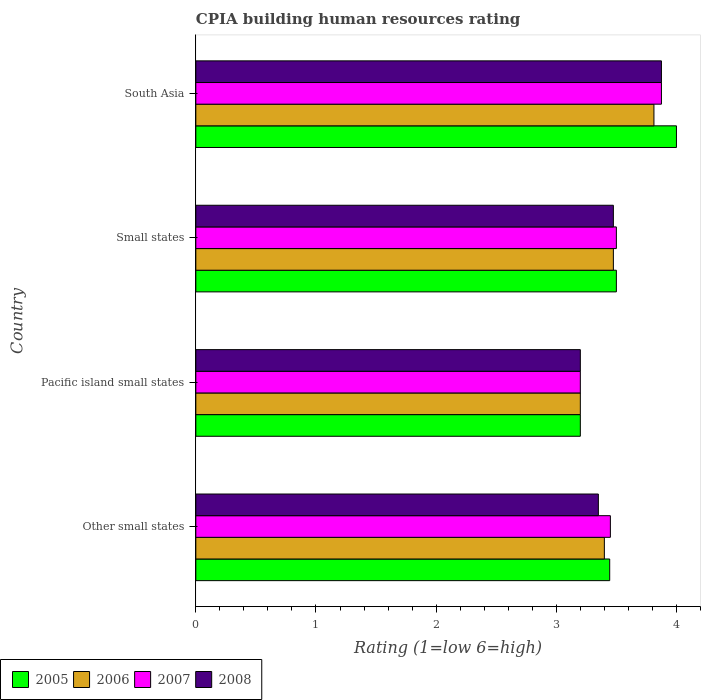How many groups of bars are there?
Keep it short and to the point. 4. Are the number of bars per tick equal to the number of legend labels?
Offer a very short reply. Yes. How many bars are there on the 2nd tick from the bottom?
Your answer should be very brief. 4. What is the label of the 2nd group of bars from the top?
Give a very brief answer. Small states. Across all countries, what is the maximum CPIA rating in 2007?
Provide a succinct answer. 3.88. Across all countries, what is the minimum CPIA rating in 2006?
Your answer should be compact. 3.2. In which country was the CPIA rating in 2005 maximum?
Your answer should be compact. South Asia. In which country was the CPIA rating in 2005 minimum?
Your response must be concise. Pacific island small states. What is the total CPIA rating in 2006 in the graph?
Your answer should be compact. 13.89. What is the difference between the CPIA rating in 2006 in Other small states and that in South Asia?
Offer a very short reply. -0.41. What is the average CPIA rating in 2008 per country?
Offer a very short reply. 3.48. What is the difference between the CPIA rating in 2006 and CPIA rating in 2005 in Small states?
Give a very brief answer. -0.02. In how many countries, is the CPIA rating in 2005 greater than 1 ?
Keep it short and to the point. 4. What is the ratio of the CPIA rating in 2006 in Pacific island small states to that in Small states?
Offer a terse response. 0.92. Is the CPIA rating in 2006 in Other small states less than that in South Asia?
Your response must be concise. Yes. Is the difference between the CPIA rating in 2006 in Other small states and Small states greater than the difference between the CPIA rating in 2005 in Other small states and Small states?
Provide a short and direct response. No. What is the difference between the highest and the lowest CPIA rating in 2007?
Give a very brief answer. 0.67. Is the sum of the CPIA rating in 2006 in Pacific island small states and Small states greater than the maximum CPIA rating in 2005 across all countries?
Your answer should be very brief. Yes. Is it the case that in every country, the sum of the CPIA rating in 2005 and CPIA rating in 2007 is greater than the sum of CPIA rating in 2008 and CPIA rating in 2006?
Ensure brevity in your answer.  No. What does the 1st bar from the top in Other small states represents?
Make the answer very short. 2008. Is it the case that in every country, the sum of the CPIA rating in 2008 and CPIA rating in 2006 is greater than the CPIA rating in 2005?
Ensure brevity in your answer.  Yes. How many bars are there?
Your answer should be very brief. 16. Are the values on the major ticks of X-axis written in scientific E-notation?
Offer a terse response. No. Does the graph contain grids?
Give a very brief answer. No. Where does the legend appear in the graph?
Provide a short and direct response. Bottom left. How many legend labels are there?
Your answer should be compact. 4. What is the title of the graph?
Offer a terse response. CPIA building human resources rating. Does "1993" appear as one of the legend labels in the graph?
Provide a short and direct response. No. What is the label or title of the Y-axis?
Your answer should be very brief. Country. What is the Rating (1=low 6=high) of 2005 in Other small states?
Provide a short and direct response. 3.44. What is the Rating (1=low 6=high) in 2007 in Other small states?
Make the answer very short. 3.45. What is the Rating (1=low 6=high) in 2008 in Other small states?
Make the answer very short. 3.35. What is the Rating (1=low 6=high) of 2005 in Pacific island small states?
Your response must be concise. 3.2. What is the Rating (1=low 6=high) of 2008 in Pacific island small states?
Ensure brevity in your answer.  3.2. What is the Rating (1=low 6=high) of 2006 in Small states?
Offer a very short reply. 3.48. What is the Rating (1=low 6=high) of 2007 in Small states?
Your answer should be compact. 3.5. What is the Rating (1=low 6=high) in 2008 in Small states?
Your answer should be very brief. 3.48. What is the Rating (1=low 6=high) in 2006 in South Asia?
Keep it short and to the point. 3.81. What is the Rating (1=low 6=high) of 2007 in South Asia?
Make the answer very short. 3.88. What is the Rating (1=low 6=high) in 2008 in South Asia?
Provide a short and direct response. 3.88. Across all countries, what is the maximum Rating (1=low 6=high) of 2006?
Offer a very short reply. 3.81. Across all countries, what is the maximum Rating (1=low 6=high) in 2007?
Give a very brief answer. 3.88. Across all countries, what is the maximum Rating (1=low 6=high) in 2008?
Offer a terse response. 3.88. Across all countries, what is the minimum Rating (1=low 6=high) of 2006?
Ensure brevity in your answer.  3.2. What is the total Rating (1=low 6=high) of 2005 in the graph?
Your answer should be very brief. 14.14. What is the total Rating (1=low 6=high) of 2006 in the graph?
Offer a very short reply. 13.89. What is the total Rating (1=low 6=high) in 2007 in the graph?
Give a very brief answer. 14.03. What is the difference between the Rating (1=low 6=high) in 2005 in Other small states and that in Pacific island small states?
Offer a terse response. 0.24. What is the difference between the Rating (1=low 6=high) of 2006 in Other small states and that in Pacific island small states?
Keep it short and to the point. 0.2. What is the difference between the Rating (1=low 6=high) in 2005 in Other small states and that in Small states?
Give a very brief answer. -0.06. What is the difference between the Rating (1=low 6=high) in 2006 in Other small states and that in Small states?
Offer a very short reply. -0.07. What is the difference between the Rating (1=low 6=high) of 2008 in Other small states and that in Small states?
Give a very brief answer. -0.12. What is the difference between the Rating (1=low 6=high) of 2005 in Other small states and that in South Asia?
Make the answer very short. -0.56. What is the difference between the Rating (1=low 6=high) of 2006 in Other small states and that in South Asia?
Provide a succinct answer. -0.41. What is the difference between the Rating (1=low 6=high) of 2007 in Other small states and that in South Asia?
Your answer should be very brief. -0.42. What is the difference between the Rating (1=low 6=high) in 2008 in Other small states and that in South Asia?
Keep it short and to the point. -0.53. What is the difference between the Rating (1=low 6=high) of 2006 in Pacific island small states and that in Small states?
Offer a very short reply. -0.28. What is the difference between the Rating (1=low 6=high) in 2007 in Pacific island small states and that in Small states?
Offer a very short reply. -0.3. What is the difference between the Rating (1=low 6=high) in 2008 in Pacific island small states and that in Small states?
Offer a very short reply. -0.28. What is the difference between the Rating (1=low 6=high) in 2006 in Pacific island small states and that in South Asia?
Your answer should be compact. -0.61. What is the difference between the Rating (1=low 6=high) of 2007 in Pacific island small states and that in South Asia?
Make the answer very short. -0.68. What is the difference between the Rating (1=low 6=high) of 2008 in Pacific island small states and that in South Asia?
Provide a succinct answer. -0.68. What is the difference between the Rating (1=low 6=high) in 2006 in Small states and that in South Asia?
Your response must be concise. -0.34. What is the difference between the Rating (1=low 6=high) in 2007 in Small states and that in South Asia?
Your response must be concise. -0.38. What is the difference between the Rating (1=low 6=high) in 2008 in Small states and that in South Asia?
Your answer should be very brief. -0.4. What is the difference between the Rating (1=low 6=high) in 2005 in Other small states and the Rating (1=low 6=high) in 2006 in Pacific island small states?
Give a very brief answer. 0.24. What is the difference between the Rating (1=low 6=high) in 2005 in Other small states and the Rating (1=low 6=high) in 2007 in Pacific island small states?
Keep it short and to the point. 0.24. What is the difference between the Rating (1=low 6=high) of 2005 in Other small states and the Rating (1=low 6=high) of 2008 in Pacific island small states?
Give a very brief answer. 0.24. What is the difference between the Rating (1=low 6=high) of 2006 in Other small states and the Rating (1=low 6=high) of 2007 in Pacific island small states?
Your answer should be very brief. 0.2. What is the difference between the Rating (1=low 6=high) of 2005 in Other small states and the Rating (1=low 6=high) of 2006 in Small states?
Make the answer very short. -0.03. What is the difference between the Rating (1=low 6=high) in 2005 in Other small states and the Rating (1=low 6=high) in 2007 in Small states?
Provide a succinct answer. -0.06. What is the difference between the Rating (1=low 6=high) in 2005 in Other small states and the Rating (1=low 6=high) in 2008 in Small states?
Your answer should be very brief. -0.03. What is the difference between the Rating (1=low 6=high) of 2006 in Other small states and the Rating (1=low 6=high) of 2007 in Small states?
Keep it short and to the point. -0.1. What is the difference between the Rating (1=low 6=high) of 2006 in Other small states and the Rating (1=low 6=high) of 2008 in Small states?
Provide a succinct answer. -0.07. What is the difference between the Rating (1=low 6=high) of 2007 in Other small states and the Rating (1=low 6=high) of 2008 in Small states?
Ensure brevity in your answer.  -0.03. What is the difference between the Rating (1=low 6=high) in 2005 in Other small states and the Rating (1=low 6=high) in 2006 in South Asia?
Your answer should be compact. -0.37. What is the difference between the Rating (1=low 6=high) of 2005 in Other small states and the Rating (1=low 6=high) of 2007 in South Asia?
Your response must be concise. -0.43. What is the difference between the Rating (1=low 6=high) in 2005 in Other small states and the Rating (1=low 6=high) in 2008 in South Asia?
Offer a very short reply. -0.43. What is the difference between the Rating (1=low 6=high) of 2006 in Other small states and the Rating (1=low 6=high) of 2007 in South Asia?
Give a very brief answer. -0.47. What is the difference between the Rating (1=low 6=high) of 2006 in Other small states and the Rating (1=low 6=high) of 2008 in South Asia?
Keep it short and to the point. -0.47. What is the difference between the Rating (1=low 6=high) of 2007 in Other small states and the Rating (1=low 6=high) of 2008 in South Asia?
Ensure brevity in your answer.  -0.42. What is the difference between the Rating (1=low 6=high) in 2005 in Pacific island small states and the Rating (1=low 6=high) in 2006 in Small states?
Your answer should be compact. -0.28. What is the difference between the Rating (1=low 6=high) of 2005 in Pacific island small states and the Rating (1=low 6=high) of 2007 in Small states?
Ensure brevity in your answer.  -0.3. What is the difference between the Rating (1=low 6=high) in 2005 in Pacific island small states and the Rating (1=low 6=high) in 2008 in Small states?
Keep it short and to the point. -0.28. What is the difference between the Rating (1=low 6=high) in 2006 in Pacific island small states and the Rating (1=low 6=high) in 2008 in Small states?
Ensure brevity in your answer.  -0.28. What is the difference between the Rating (1=low 6=high) of 2007 in Pacific island small states and the Rating (1=low 6=high) of 2008 in Small states?
Give a very brief answer. -0.28. What is the difference between the Rating (1=low 6=high) in 2005 in Pacific island small states and the Rating (1=low 6=high) in 2006 in South Asia?
Keep it short and to the point. -0.61. What is the difference between the Rating (1=low 6=high) of 2005 in Pacific island small states and the Rating (1=low 6=high) of 2007 in South Asia?
Provide a short and direct response. -0.68. What is the difference between the Rating (1=low 6=high) in 2005 in Pacific island small states and the Rating (1=low 6=high) in 2008 in South Asia?
Offer a very short reply. -0.68. What is the difference between the Rating (1=low 6=high) in 2006 in Pacific island small states and the Rating (1=low 6=high) in 2007 in South Asia?
Provide a succinct answer. -0.68. What is the difference between the Rating (1=low 6=high) in 2006 in Pacific island small states and the Rating (1=low 6=high) in 2008 in South Asia?
Provide a succinct answer. -0.68. What is the difference between the Rating (1=low 6=high) in 2007 in Pacific island small states and the Rating (1=low 6=high) in 2008 in South Asia?
Your response must be concise. -0.68. What is the difference between the Rating (1=low 6=high) of 2005 in Small states and the Rating (1=low 6=high) of 2006 in South Asia?
Provide a succinct answer. -0.31. What is the difference between the Rating (1=low 6=high) of 2005 in Small states and the Rating (1=low 6=high) of 2007 in South Asia?
Your response must be concise. -0.38. What is the difference between the Rating (1=low 6=high) of 2005 in Small states and the Rating (1=low 6=high) of 2008 in South Asia?
Keep it short and to the point. -0.38. What is the difference between the Rating (1=low 6=high) in 2007 in Small states and the Rating (1=low 6=high) in 2008 in South Asia?
Keep it short and to the point. -0.38. What is the average Rating (1=low 6=high) of 2005 per country?
Your answer should be very brief. 3.54. What is the average Rating (1=low 6=high) of 2006 per country?
Your response must be concise. 3.47. What is the average Rating (1=low 6=high) of 2007 per country?
Offer a terse response. 3.51. What is the average Rating (1=low 6=high) of 2008 per country?
Keep it short and to the point. 3.48. What is the difference between the Rating (1=low 6=high) in 2005 and Rating (1=low 6=high) in 2006 in Other small states?
Make the answer very short. 0.04. What is the difference between the Rating (1=low 6=high) in 2005 and Rating (1=low 6=high) in 2007 in Other small states?
Keep it short and to the point. -0.01. What is the difference between the Rating (1=low 6=high) of 2005 and Rating (1=low 6=high) of 2008 in Other small states?
Give a very brief answer. 0.09. What is the difference between the Rating (1=low 6=high) in 2006 and Rating (1=low 6=high) in 2007 in Other small states?
Offer a terse response. -0.05. What is the difference between the Rating (1=low 6=high) of 2007 and Rating (1=low 6=high) of 2008 in Other small states?
Give a very brief answer. 0.1. What is the difference between the Rating (1=low 6=high) in 2005 and Rating (1=low 6=high) in 2008 in Pacific island small states?
Make the answer very short. 0. What is the difference between the Rating (1=low 6=high) in 2006 and Rating (1=low 6=high) in 2008 in Pacific island small states?
Offer a very short reply. 0. What is the difference between the Rating (1=low 6=high) in 2007 and Rating (1=low 6=high) in 2008 in Pacific island small states?
Your answer should be compact. 0. What is the difference between the Rating (1=low 6=high) in 2005 and Rating (1=low 6=high) in 2006 in Small states?
Your answer should be very brief. 0.03. What is the difference between the Rating (1=low 6=high) in 2005 and Rating (1=low 6=high) in 2007 in Small states?
Keep it short and to the point. 0. What is the difference between the Rating (1=low 6=high) of 2005 and Rating (1=low 6=high) of 2008 in Small states?
Your answer should be very brief. 0.03. What is the difference between the Rating (1=low 6=high) of 2006 and Rating (1=low 6=high) of 2007 in Small states?
Provide a short and direct response. -0.03. What is the difference between the Rating (1=low 6=high) of 2006 and Rating (1=low 6=high) of 2008 in Small states?
Offer a terse response. 0. What is the difference between the Rating (1=low 6=high) of 2007 and Rating (1=low 6=high) of 2008 in Small states?
Provide a short and direct response. 0.03. What is the difference between the Rating (1=low 6=high) in 2005 and Rating (1=low 6=high) in 2006 in South Asia?
Your answer should be compact. 0.19. What is the difference between the Rating (1=low 6=high) in 2005 and Rating (1=low 6=high) in 2008 in South Asia?
Ensure brevity in your answer.  0.12. What is the difference between the Rating (1=low 6=high) of 2006 and Rating (1=low 6=high) of 2007 in South Asia?
Offer a terse response. -0.06. What is the difference between the Rating (1=low 6=high) of 2006 and Rating (1=low 6=high) of 2008 in South Asia?
Offer a very short reply. -0.06. What is the ratio of the Rating (1=low 6=high) of 2005 in Other small states to that in Pacific island small states?
Ensure brevity in your answer.  1.08. What is the ratio of the Rating (1=low 6=high) in 2006 in Other small states to that in Pacific island small states?
Your response must be concise. 1.06. What is the ratio of the Rating (1=low 6=high) of 2007 in Other small states to that in Pacific island small states?
Provide a short and direct response. 1.08. What is the ratio of the Rating (1=low 6=high) in 2008 in Other small states to that in Pacific island small states?
Keep it short and to the point. 1.05. What is the ratio of the Rating (1=low 6=high) of 2005 in Other small states to that in Small states?
Offer a terse response. 0.98. What is the ratio of the Rating (1=low 6=high) of 2006 in Other small states to that in Small states?
Provide a short and direct response. 0.98. What is the ratio of the Rating (1=low 6=high) of 2007 in Other small states to that in Small states?
Ensure brevity in your answer.  0.99. What is the ratio of the Rating (1=low 6=high) in 2005 in Other small states to that in South Asia?
Offer a terse response. 0.86. What is the ratio of the Rating (1=low 6=high) of 2006 in Other small states to that in South Asia?
Ensure brevity in your answer.  0.89. What is the ratio of the Rating (1=low 6=high) of 2007 in Other small states to that in South Asia?
Keep it short and to the point. 0.89. What is the ratio of the Rating (1=low 6=high) of 2008 in Other small states to that in South Asia?
Provide a short and direct response. 0.86. What is the ratio of the Rating (1=low 6=high) in 2005 in Pacific island small states to that in Small states?
Keep it short and to the point. 0.91. What is the ratio of the Rating (1=low 6=high) of 2006 in Pacific island small states to that in Small states?
Provide a succinct answer. 0.92. What is the ratio of the Rating (1=low 6=high) of 2007 in Pacific island small states to that in Small states?
Your answer should be compact. 0.91. What is the ratio of the Rating (1=low 6=high) in 2008 in Pacific island small states to that in Small states?
Provide a short and direct response. 0.92. What is the ratio of the Rating (1=low 6=high) in 2005 in Pacific island small states to that in South Asia?
Give a very brief answer. 0.8. What is the ratio of the Rating (1=low 6=high) in 2006 in Pacific island small states to that in South Asia?
Ensure brevity in your answer.  0.84. What is the ratio of the Rating (1=low 6=high) of 2007 in Pacific island small states to that in South Asia?
Offer a terse response. 0.83. What is the ratio of the Rating (1=low 6=high) in 2008 in Pacific island small states to that in South Asia?
Provide a short and direct response. 0.83. What is the ratio of the Rating (1=low 6=high) in 2005 in Small states to that in South Asia?
Your answer should be very brief. 0.88. What is the ratio of the Rating (1=low 6=high) of 2006 in Small states to that in South Asia?
Make the answer very short. 0.91. What is the ratio of the Rating (1=low 6=high) in 2007 in Small states to that in South Asia?
Offer a very short reply. 0.9. What is the ratio of the Rating (1=low 6=high) in 2008 in Small states to that in South Asia?
Offer a very short reply. 0.9. What is the difference between the highest and the second highest Rating (1=low 6=high) of 2006?
Your answer should be very brief. 0.34. What is the difference between the highest and the second highest Rating (1=low 6=high) of 2008?
Provide a short and direct response. 0.4. What is the difference between the highest and the lowest Rating (1=low 6=high) of 2005?
Your response must be concise. 0.8. What is the difference between the highest and the lowest Rating (1=low 6=high) of 2006?
Your answer should be compact. 0.61. What is the difference between the highest and the lowest Rating (1=low 6=high) of 2007?
Offer a very short reply. 0.68. What is the difference between the highest and the lowest Rating (1=low 6=high) of 2008?
Keep it short and to the point. 0.68. 